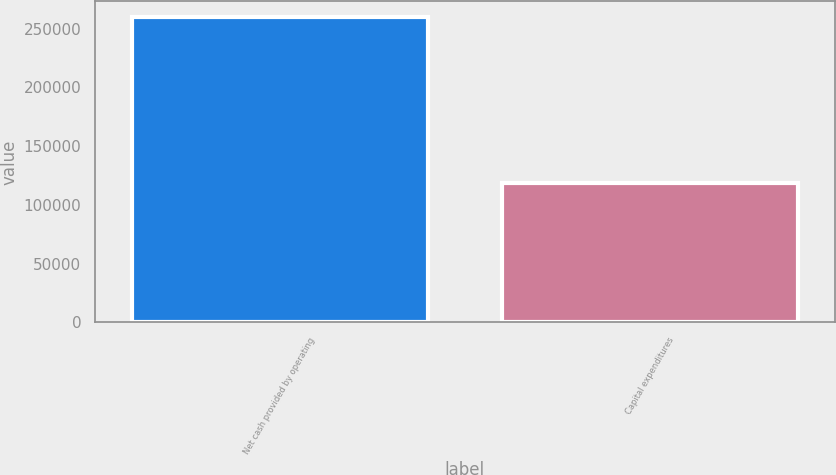<chart> <loc_0><loc_0><loc_500><loc_500><bar_chart><fcel>Net cash provided by operating<fcel>Capital expenditures<nl><fcel>260039<fcel>118912<nl></chart> 